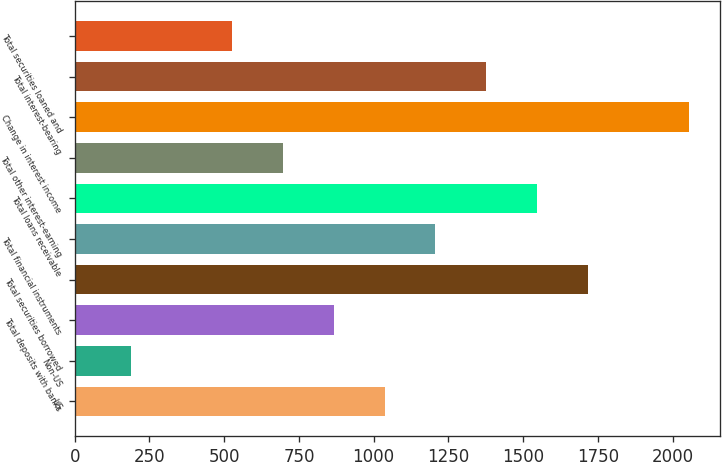Convert chart. <chart><loc_0><loc_0><loc_500><loc_500><bar_chart><fcel>US<fcel>Non-US<fcel>Total deposits with banks<fcel>Total securities borrowed<fcel>Total financial instruments<fcel>Total loans receivable<fcel>Total other interest-earning<fcel>Change in interest income<fcel>Total interest-bearing<fcel>Total securities loaned and<nl><fcel>1036.4<fcel>186.9<fcel>866.5<fcel>1716<fcel>1206.3<fcel>1546.1<fcel>696.6<fcel>2055.8<fcel>1376.2<fcel>526.7<nl></chart> 